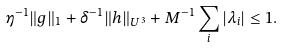Convert formula to latex. <formula><loc_0><loc_0><loc_500><loc_500>\eta ^ { - 1 } \| g \| _ { 1 } + \delta ^ { - 1 } \| h \| _ { U ^ { 3 } } + M ^ { - 1 } \sum _ { i } | \lambda _ { i } | \leq 1 .</formula> 